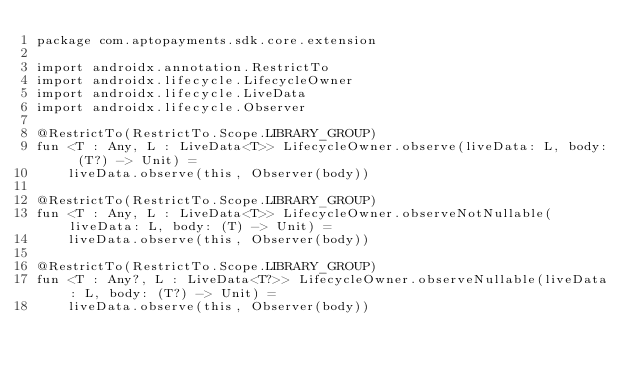<code> <loc_0><loc_0><loc_500><loc_500><_Kotlin_>package com.aptopayments.sdk.core.extension

import androidx.annotation.RestrictTo
import androidx.lifecycle.LifecycleOwner
import androidx.lifecycle.LiveData
import androidx.lifecycle.Observer

@RestrictTo(RestrictTo.Scope.LIBRARY_GROUP)
fun <T : Any, L : LiveData<T>> LifecycleOwner.observe(liveData: L, body: (T?) -> Unit) =
    liveData.observe(this, Observer(body))

@RestrictTo(RestrictTo.Scope.LIBRARY_GROUP)
fun <T : Any, L : LiveData<T>> LifecycleOwner.observeNotNullable(liveData: L, body: (T) -> Unit) =
    liveData.observe(this, Observer(body))

@RestrictTo(RestrictTo.Scope.LIBRARY_GROUP)
fun <T : Any?, L : LiveData<T?>> LifecycleOwner.observeNullable(liveData: L, body: (T?) -> Unit) =
    liveData.observe(this, Observer(body))
</code> 